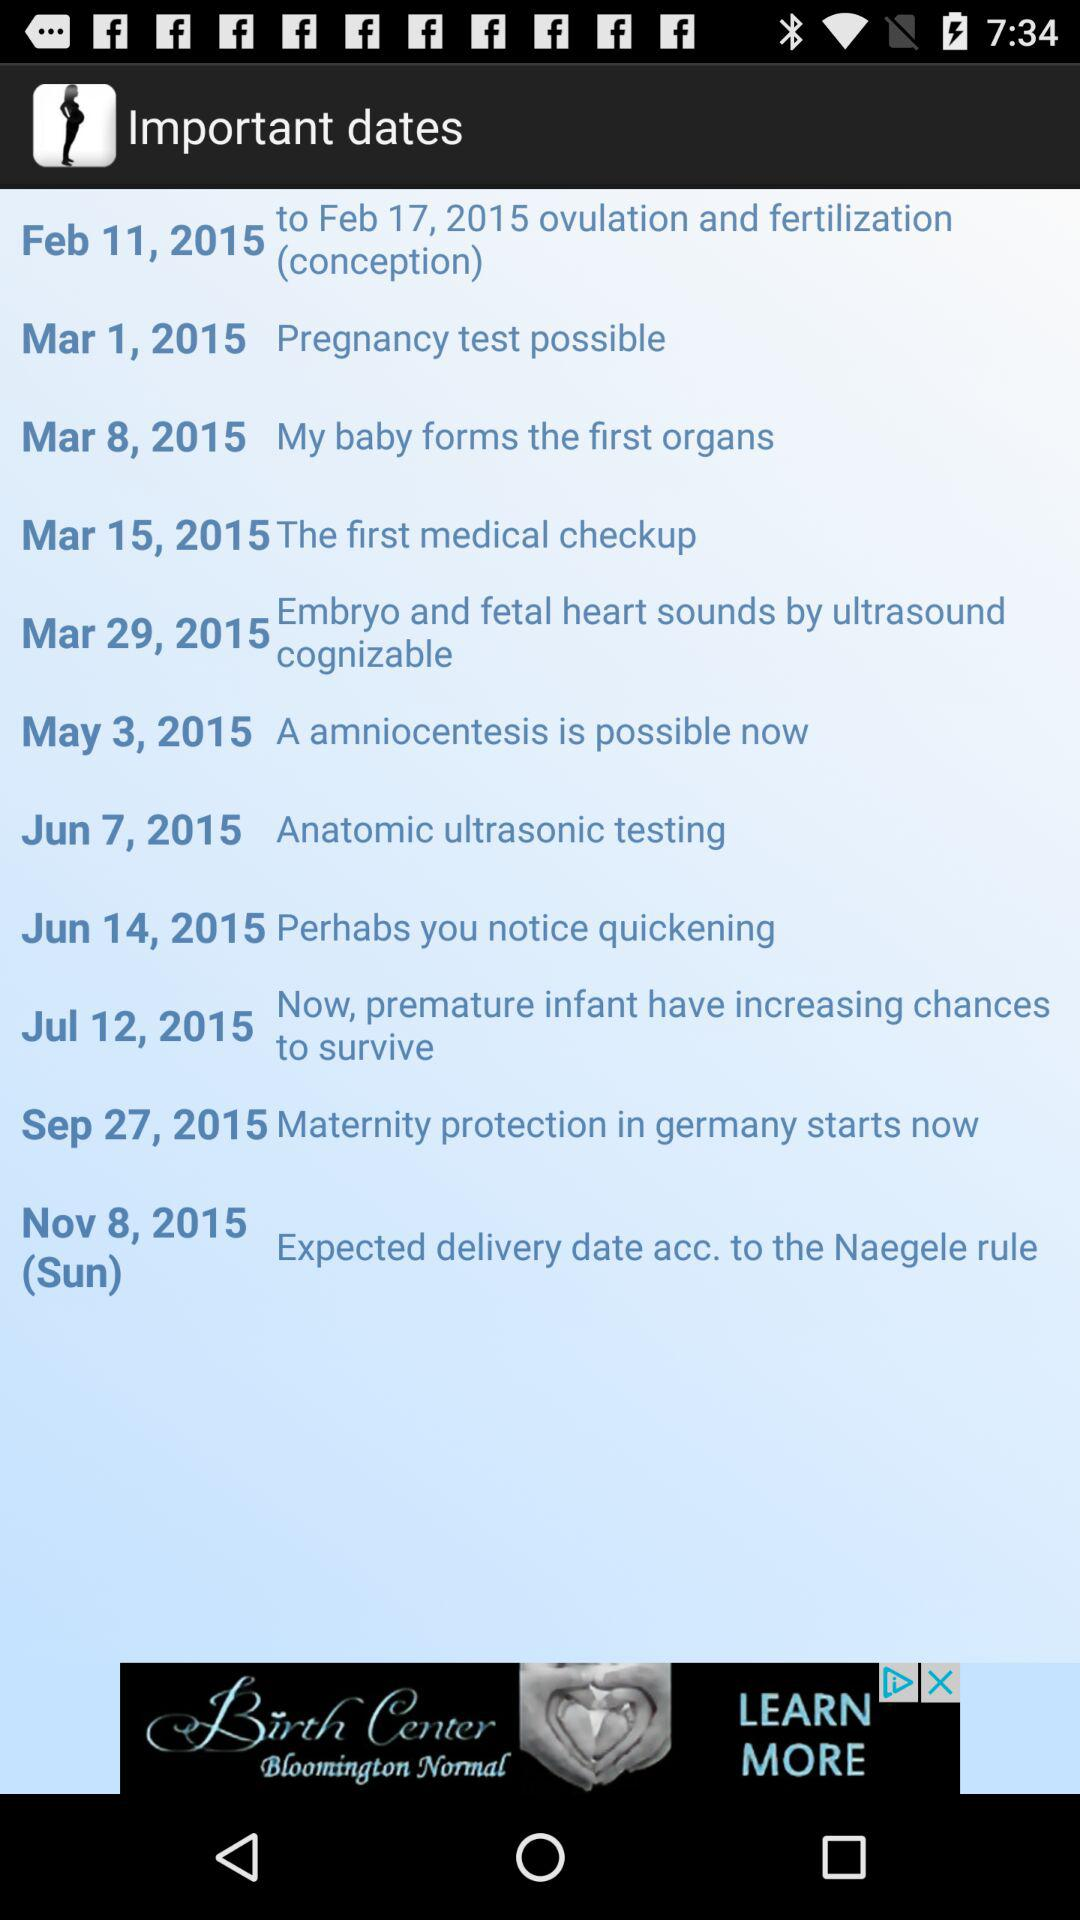What happened on March 8, 2015? On March 8, 2015, "My baby forms the first organs". 